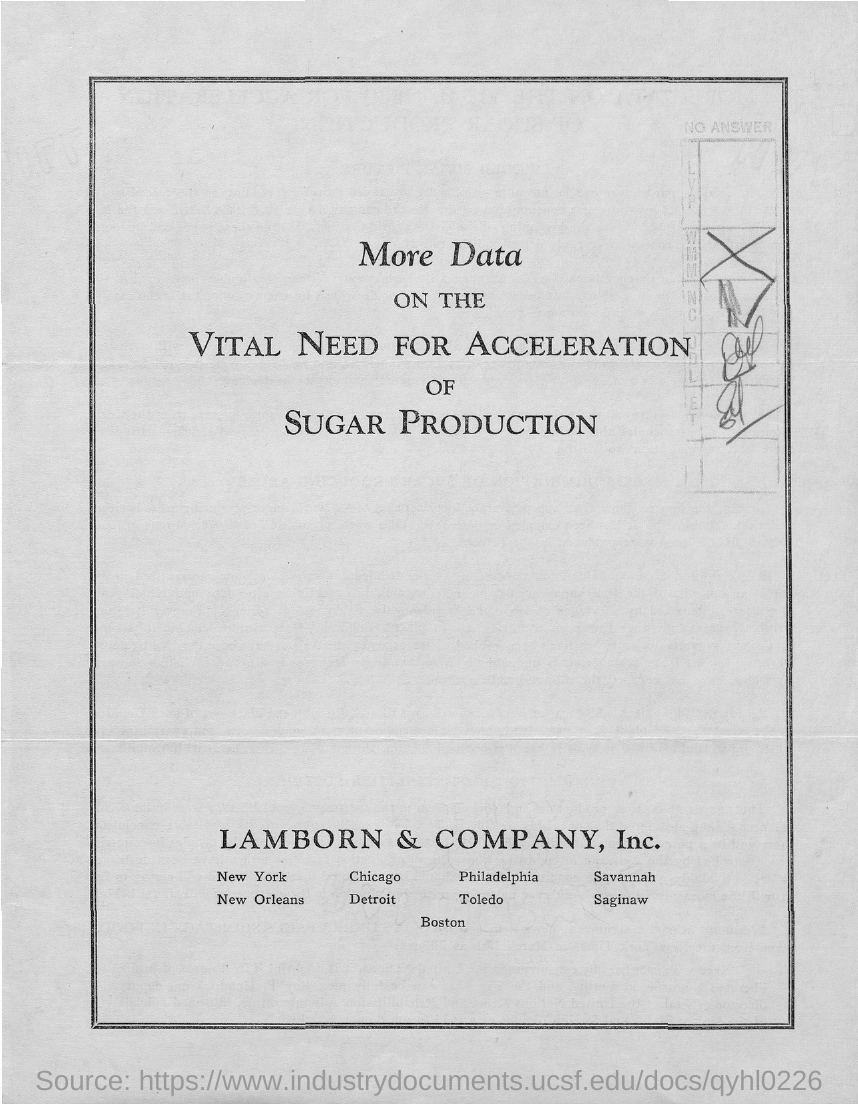List a handful of essential elements in this visual. The title of the document is 'The Vital Need for Accelerating Sugar Production' and contains additional data and information on the importance of increasing sugar production. 